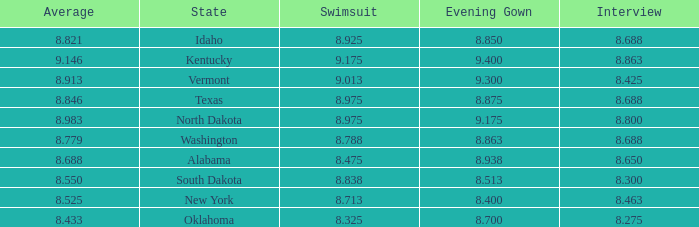What is the average interview score from Kentucky? 8.863. 